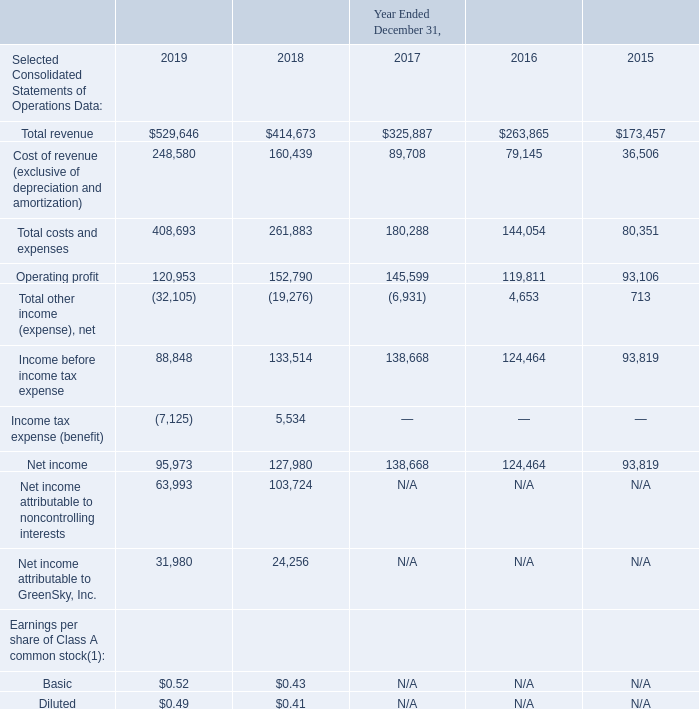ITEM 6. SELECTED FINANCIAL DATA (Dollars in thousands, except per share data and unless otherwise indicated)
The Selected Consolidated Statements of Operations Data for the years ended December 31, 2019, 2018 and 2017 and the Selected Consolidated Balance Sheet Data as of December 31, 2019 and 2018 were derived from our Consolidated Financial Statements included in Item 8 of this Form 10-K. The Selected Consolidated Statements of Operations Data for the years ended December 31, 2016 and 2015 and the Selected Consolidated Balance Sheet Data as of December 31, 2017 and 2016 were derived from our audited Consolidated Financial Statements not included in this Form 10-K. Our historical results are not necessarily indicative of the results to be expected in the future. You should read the following financial information together with the information under Item 7 "Management's Discussion and Analysis of Financial Condition and Results of Operations" and the Consolidated Financial Statements and related notes included in Item 8.
GS Holdings and GSLLC are our predecessors for accounting purposes and, accordingly, amounts prior to the Reorganization Transactions and IPO represent the historical consolidated operations of either GS Holdings or GSLLC and its subsidiaries. The amounts as of December 31, 2019 and 2018 and during the period from May 24, 2018 through December 31, 2019 represent those of consolidated GreenSky, Inc. and its subsidiaries. Prior to the Reorganization Transactions and IPO, GreenSky, Inc. did not engage in any business or other activities except in connection with its formation and initial capitalization. See Note 1 to the Notes to Consolidated Financial Statements in Item 8 for further information on our organization.
(1) Basic and diluted earnings per share of Class A common stock are applicable only for the period from May 24, 2018 through December 31, 2019, which is the period following the Reorganization Transactions and IPO. See Note 2 to the Notes to Consolidated Financial Statements in Item 8 for further information.
Which years does the table provide information for the company's Selected Consolidated Statements of Operations Data? 2019, 2018, 2017, 2016. What was the total revenue in 2015?
Answer scale should be: thousand. 173,457. What was the operating profit in 2017?
Answer scale should be: thousand. 145,599. How many years did Total costs and expenses exceed $200,000 thousand? 2019##2018
Answer: 2. What was the change in the cost of revenue between 2017 and 2018?
Answer scale should be: thousand. 160,439-89,708
Answer: 70731. What was the percentage change in operating profit between 2015 and 2016?
Answer scale should be: percent. (119,811-93,106)/93,106
Answer: 28.68. 